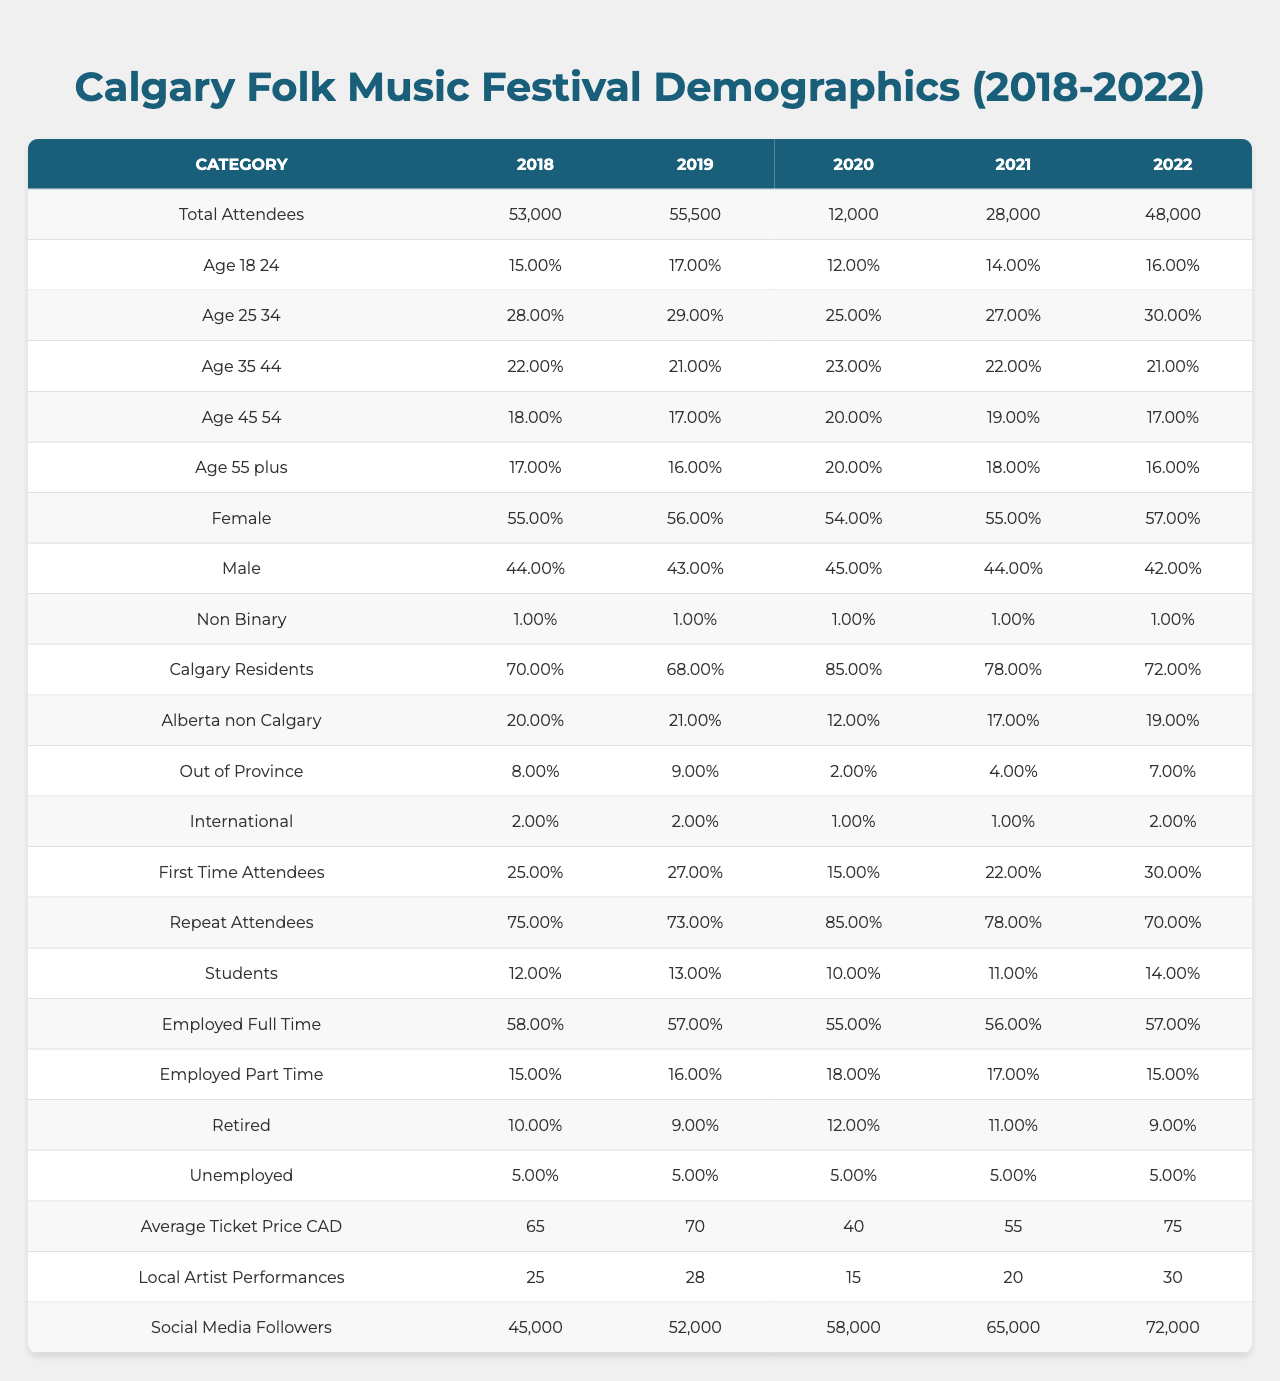What's the total number of attendees in 2022? The table shows that the total number of attendees in 2022 is listed under the "Total Attendees" column for that year, which is 48,000.
Answer: 48,000 What percentage of attendees were aged 25 to 34 in 2019? The percentage of attendees aged 25 to 34 in 2019 can be found in the "Age 25-34" row for that year, which is 29%.
Answer: 29% In which year did the Calgary Folk Music Festival see the highest number of first-time attendees? To find the year with the highest proportion of first-time attendees, we look at the "First Time Attendees" percentages for each year. The highest percentage is 30% in 2022.
Answer: 2022 What was the average ticket price in 2020? The average ticket price for 2020 is shown in the "Average Ticket Price CAD" column for that year, which is 40.
Answer: 40 How did the proportion of Calgary residents change from 2018 to 2021? The percentage of Calgary residents in 2018 was 70%, and it decreased to 78% in 2021. We take the difference: 78 - 70 = 8. This indicates that there was an increase in the proportion of Calgary residents by 8%.
Answer: Increased by 8% Was there a year when the number of employed full-time attendees was below 55%? By examining the "Employed Full Time" row, we see that the percentages for each year were 58%, 57%, 55%, 56%, and 57%. There were no years below 55%.
Answer: No Which age group had the lowest percentage of attendees in 2020? By checking the "Age" rows in 2020, the percentages were: 12% for ages 18-24, 25% for 25-34, 23% for 35-44, 20% for 45-54, and 20% for 55+. The age group 18-24 had the lowest at 12%.
Answer: Ages 18-24 What was the change in the number of local artist performances from 2018 to 2022? The number of local artist performances in 2018 was 25, while in 2022 it was 30. The change is calculated as: 30 - 25 = 5 more performances in 2022 compared to 2018.
Answer: Increased by 5 What was the average percentage of female attendees over the past 5 years? The percentages of female attendees are: 55%, 56%, 54%, 55%, and 57%. To find the average, we sum these up (55 + 56 + 54 + 55 + 57 = 277) and divide by 5. The average is 277 / 5 = 55.4%.
Answer: 55.4% Which year had the most repeat attendees? The "Repeat Attendees" row shows the values for each year: 75%, 73%, 85%, 78%, and 70%. The highest proportion of repeat attendees was 85% in 2020.
Answer: 2020 What is the ratio of employed part-time attendees to unemployed attendees in 2021? For 2021, the proportion of employed part-time attendees is 17% and the unemployed attendees are 5%. The ratio is therefore 17:5.
Answer: 17:5 